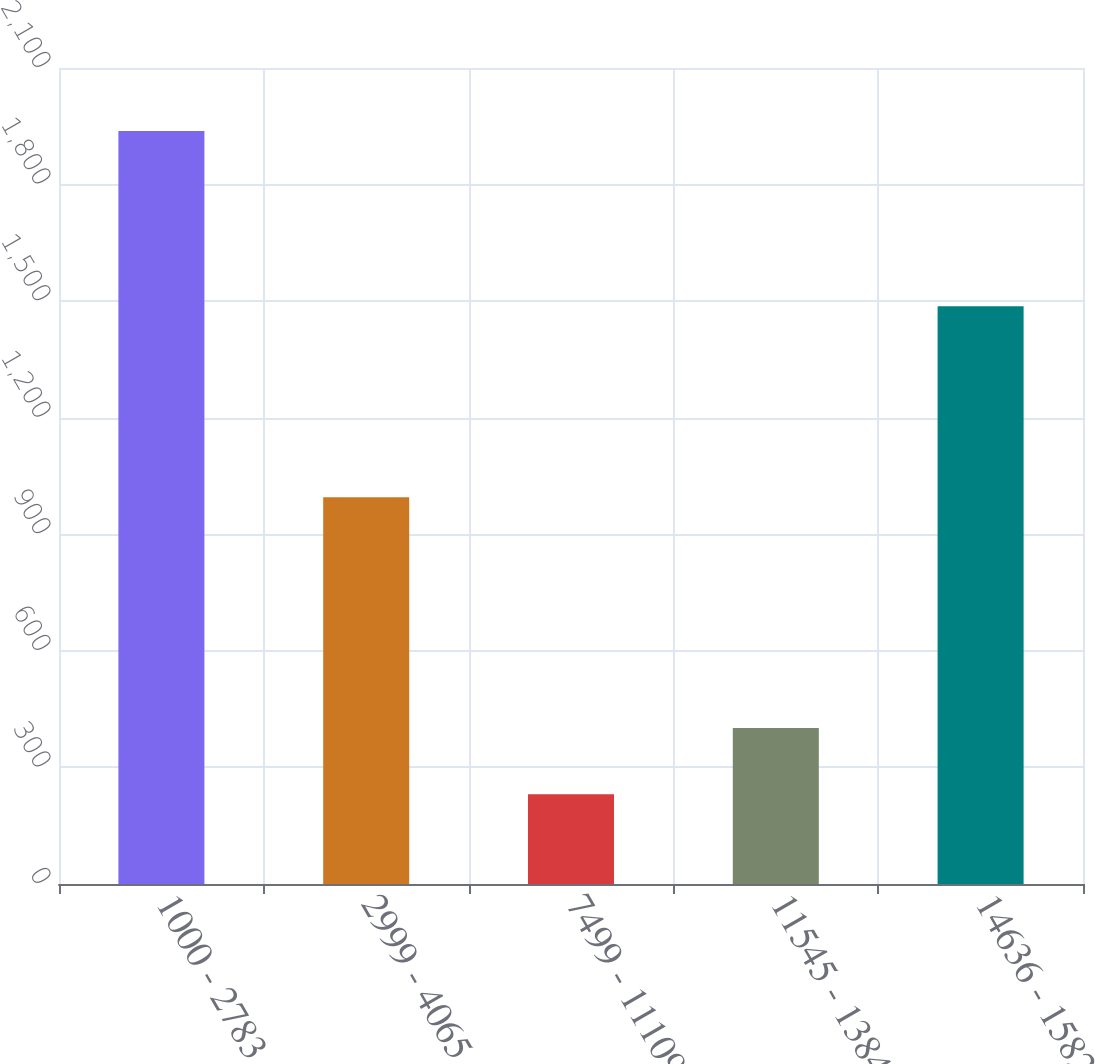Convert chart to OTSL. <chart><loc_0><loc_0><loc_500><loc_500><bar_chart><fcel>1000 - 2783<fcel>2999 - 4065<fcel>7499 - 11109<fcel>11545 - 13847<fcel>14636 - 15824<nl><fcel>1938<fcel>995<fcel>231<fcel>401.7<fcel>1487<nl></chart> 